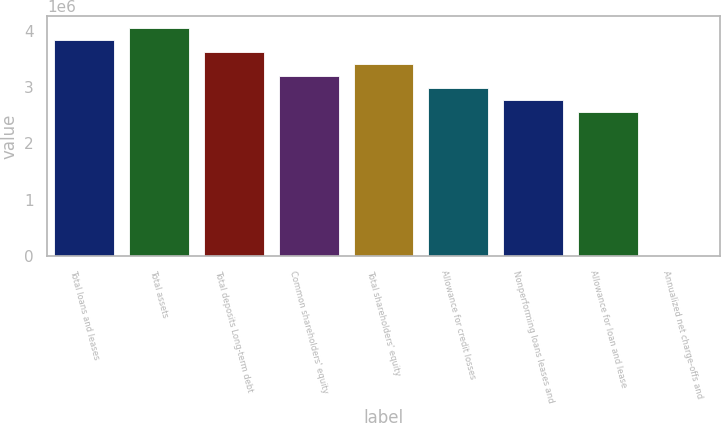Convert chart to OTSL. <chart><loc_0><loc_0><loc_500><loc_500><bar_chart><fcel>Total loans and leases<fcel>Total assets<fcel>Total deposits Long-term debt<fcel>Common shareholders' equity<fcel>Total shareholders' equity<fcel>Allowance for credit losses<fcel>Nonperforming loans leases and<fcel>Allowance for loan and lease<fcel>Annualized net charge-offs and<nl><fcel>3.84277e+06<fcel>4.05626e+06<fcel>3.62929e+06<fcel>3.20231e+06<fcel>3.4158e+06<fcel>2.98882e+06<fcel>2.77534e+06<fcel>2.56185e+06<fcel>1<nl></chart> 